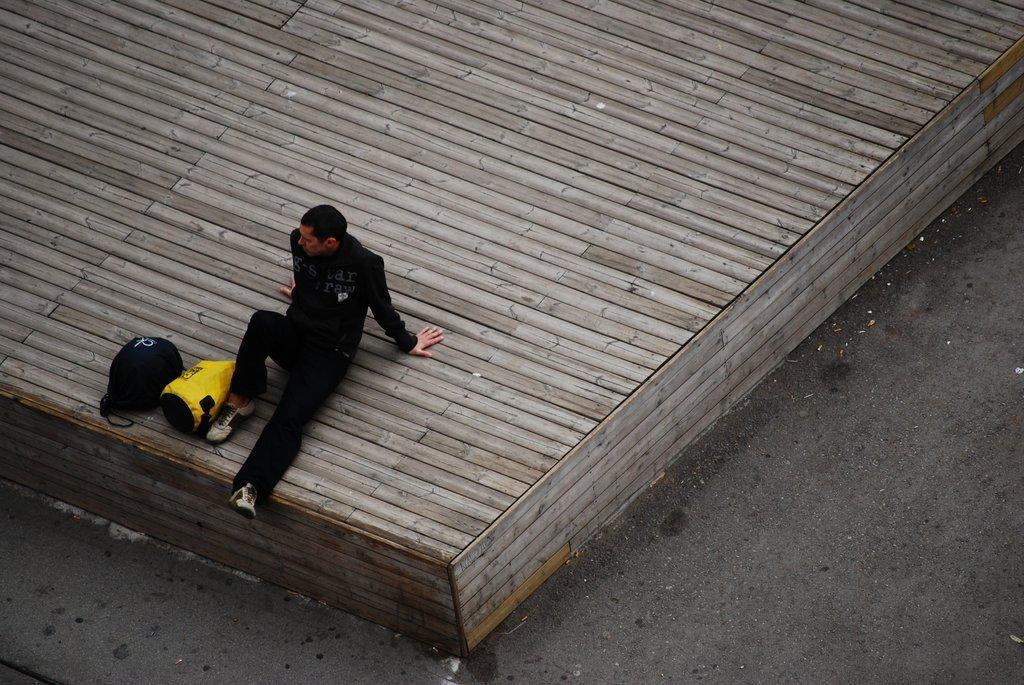Describe this image in one or two sentences. In this image we can see person wearing black color dress, white color shoes sitting on the wooden surface there are two bags beside him which are of different colors like yellow and blue. 